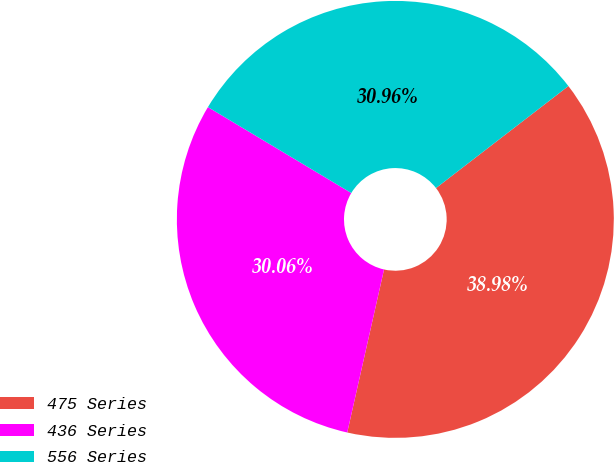<chart> <loc_0><loc_0><loc_500><loc_500><pie_chart><fcel>475 Series<fcel>436 Series<fcel>556 Series<nl><fcel>38.98%<fcel>30.06%<fcel>30.96%<nl></chart> 